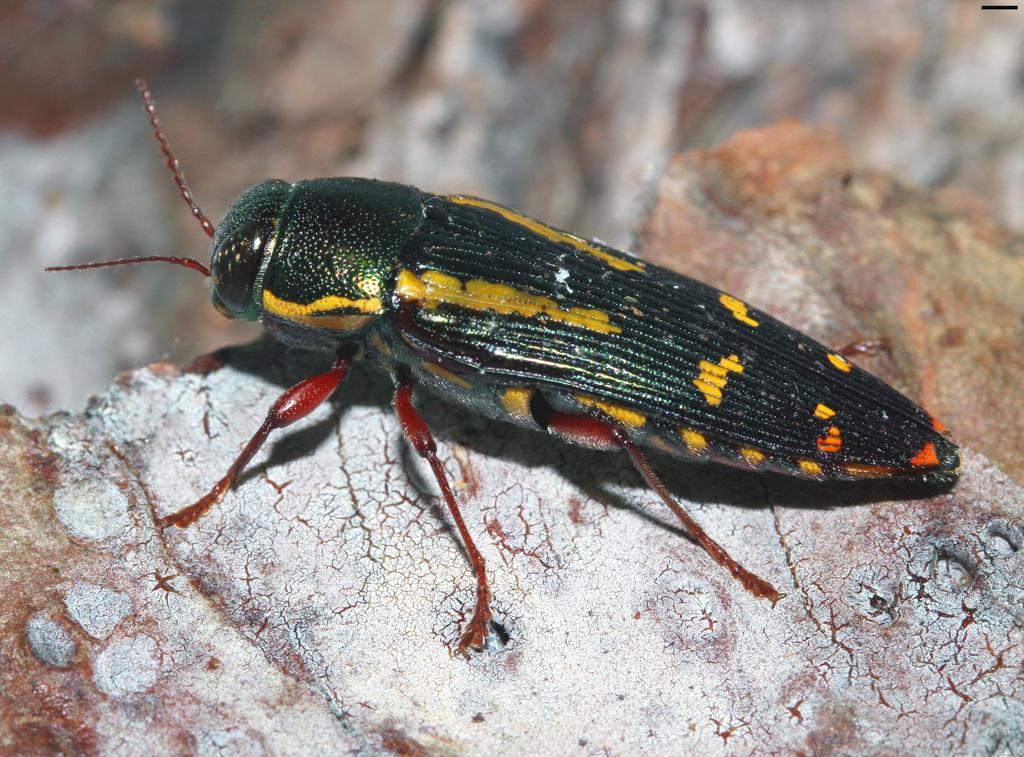Describe this image in one or two sentences. This picture shows a insect. it is green, yellow and red in color. 